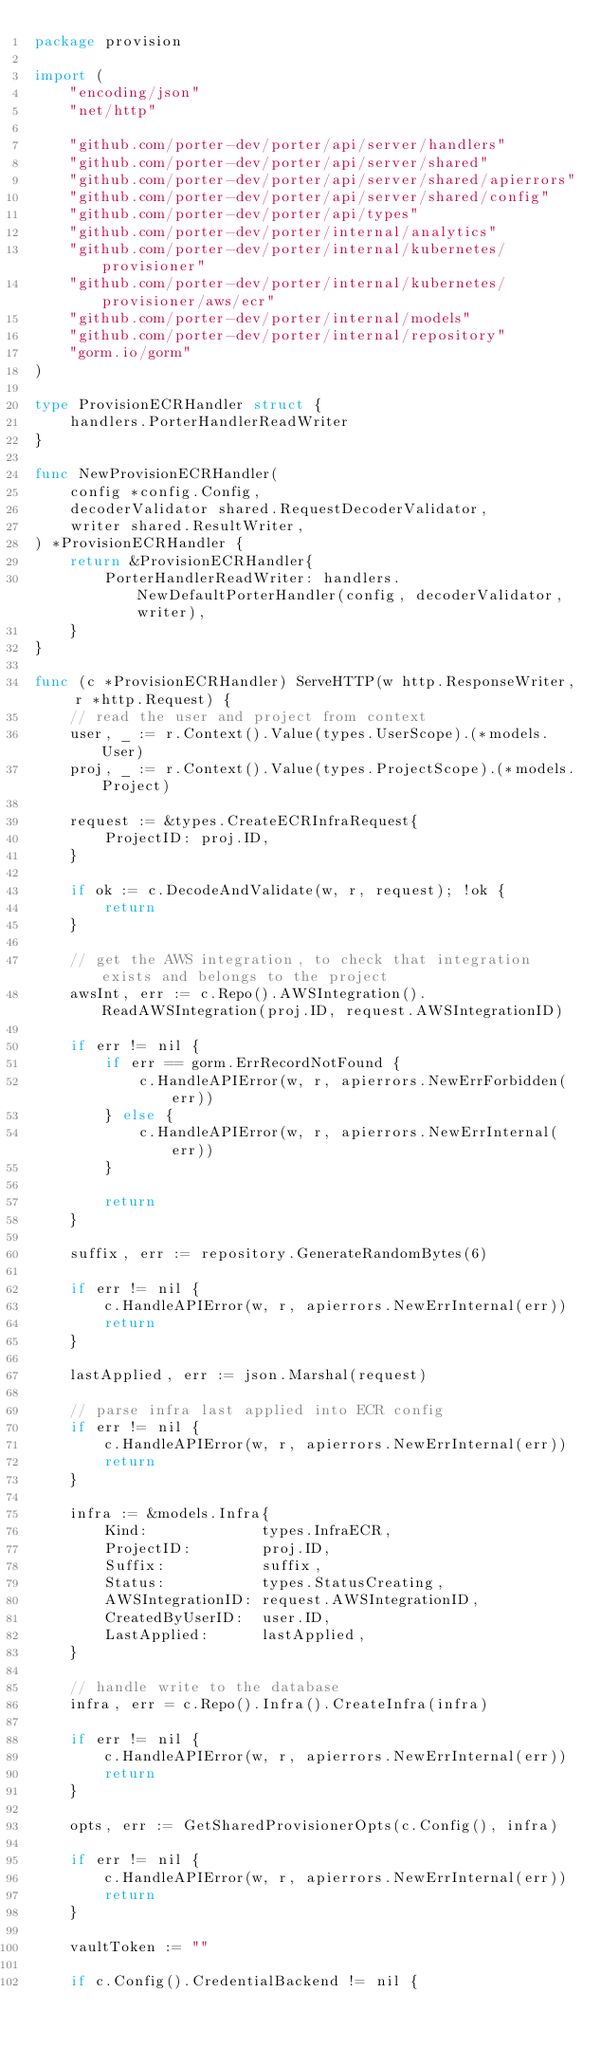<code> <loc_0><loc_0><loc_500><loc_500><_Go_>package provision

import (
	"encoding/json"
	"net/http"

	"github.com/porter-dev/porter/api/server/handlers"
	"github.com/porter-dev/porter/api/server/shared"
	"github.com/porter-dev/porter/api/server/shared/apierrors"
	"github.com/porter-dev/porter/api/server/shared/config"
	"github.com/porter-dev/porter/api/types"
	"github.com/porter-dev/porter/internal/analytics"
	"github.com/porter-dev/porter/internal/kubernetes/provisioner"
	"github.com/porter-dev/porter/internal/kubernetes/provisioner/aws/ecr"
	"github.com/porter-dev/porter/internal/models"
	"github.com/porter-dev/porter/internal/repository"
	"gorm.io/gorm"
)

type ProvisionECRHandler struct {
	handlers.PorterHandlerReadWriter
}

func NewProvisionECRHandler(
	config *config.Config,
	decoderValidator shared.RequestDecoderValidator,
	writer shared.ResultWriter,
) *ProvisionECRHandler {
	return &ProvisionECRHandler{
		PorterHandlerReadWriter: handlers.NewDefaultPorterHandler(config, decoderValidator, writer),
	}
}

func (c *ProvisionECRHandler) ServeHTTP(w http.ResponseWriter, r *http.Request) {
	// read the user and project from context
	user, _ := r.Context().Value(types.UserScope).(*models.User)
	proj, _ := r.Context().Value(types.ProjectScope).(*models.Project)

	request := &types.CreateECRInfraRequest{
		ProjectID: proj.ID,
	}

	if ok := c.DecodeAndValidate(w, r, request); !ok {
		return
	}

	// get the AWS integration, to check that integration exists and belongs to the project
	awsInt, err := c.Repo().AWSIntegration().ReadAWSIntegration(proj.ID, request.AWSIntegrationID)

	if err != nil {
		if err == gorm.ErrRecordNotFound {
			c.HandleAPIError(w, r, apierrors.NewErrForbidden(err))
		} else {
			c.HandleAPIError(w, r, apierrors.NewErrInternal(err))
		}

		return
	}

	suffix, err := repository.GenerateRandomBytes(6)

	if err != nil {
		c.HandleAPIError(w, r, apierrors.NewErrInternal(err))
		return
	}

	lastApplied, err := json.Marshal(request)

	// parse infra last applied into ECR config
	if err != nil {
		c.HandleAPIError(w, r, apierrors.NewErrInternal(err))
		return
	}

	infra := &models.Infra{
		Kind:             types.InfraECR,
		ProjectID:        proj.ID,
		Suffix:           suffix,
		Status:           types.StatusCreating,
		AWSIntegrationID: request.AWSIntegrationID,
		CreatedByUserID:  user.ID,
		LastApplied:      lastApplied,
	}

	// handle write to the database
	infra, err = c.Repo().Infra().CreateInfra(infra)

	if err != nil {
		c.HandleAPIError(w, r, apierrors.NewErrInternal(err))
		return
	}

	opts, err := GetSharedProvisionerOpts(c.Config(), infra)

	if err != nil {
		c.HandleAPIError(w, r, apierrors.NewErrInternal(err))
		return
	}

	vaultToken := ""

	if c.Config().CredentialBackend != nil {</code> 